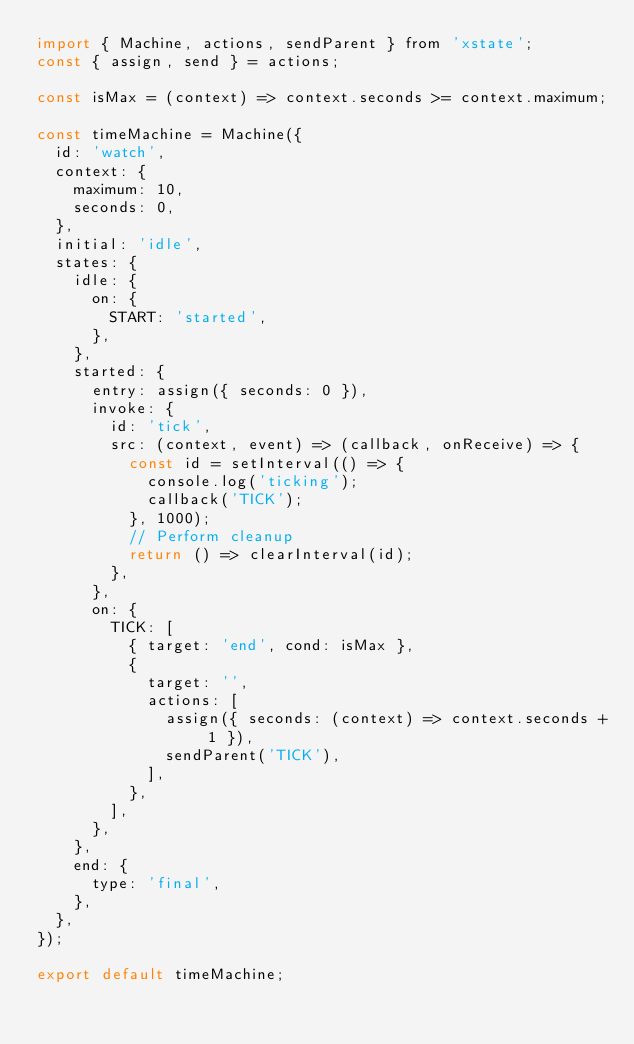<code> <loc_0><loc_0><loc_500><loc_500><_JavaScript_>import { Machine, actions, sendParent } from 'xstate';
const { assign, send } = actions;

const isMax = (context) => context.seconds >= context.maximum;

const timeMachine = Machine({
  id: 'watch',
  context: {
    maximum: 10,
    seconds: 0,
  },
  initial: 'idle',
  states: {
    idle: {
      on: {
        START: 'started',
      },
    },
    started: {
      entry: assign({ seconds: 0 }),
      invoke: {
        id: 'tick',
        src: (context, event) => (callback, onReceive) => {
          const id = setInterval(() => {
            console.log('ticking');
            callback('TICK');
          }, 1000);
          // Perform cleanup
          return () => clearInterval(id);
        },
      },
      on: {
        TICK: [
          { target: 'end', cond: isMax },
          {
            target: '',
            actions: [
              assign({ seconds: (context) => context.seconds + 1 }),
              sendParent('TICK'),
            ],
          },
        ],
      },
    },
    end: {
      type: 'final',
    },
  },
});

export default timeMachine;
</code> 